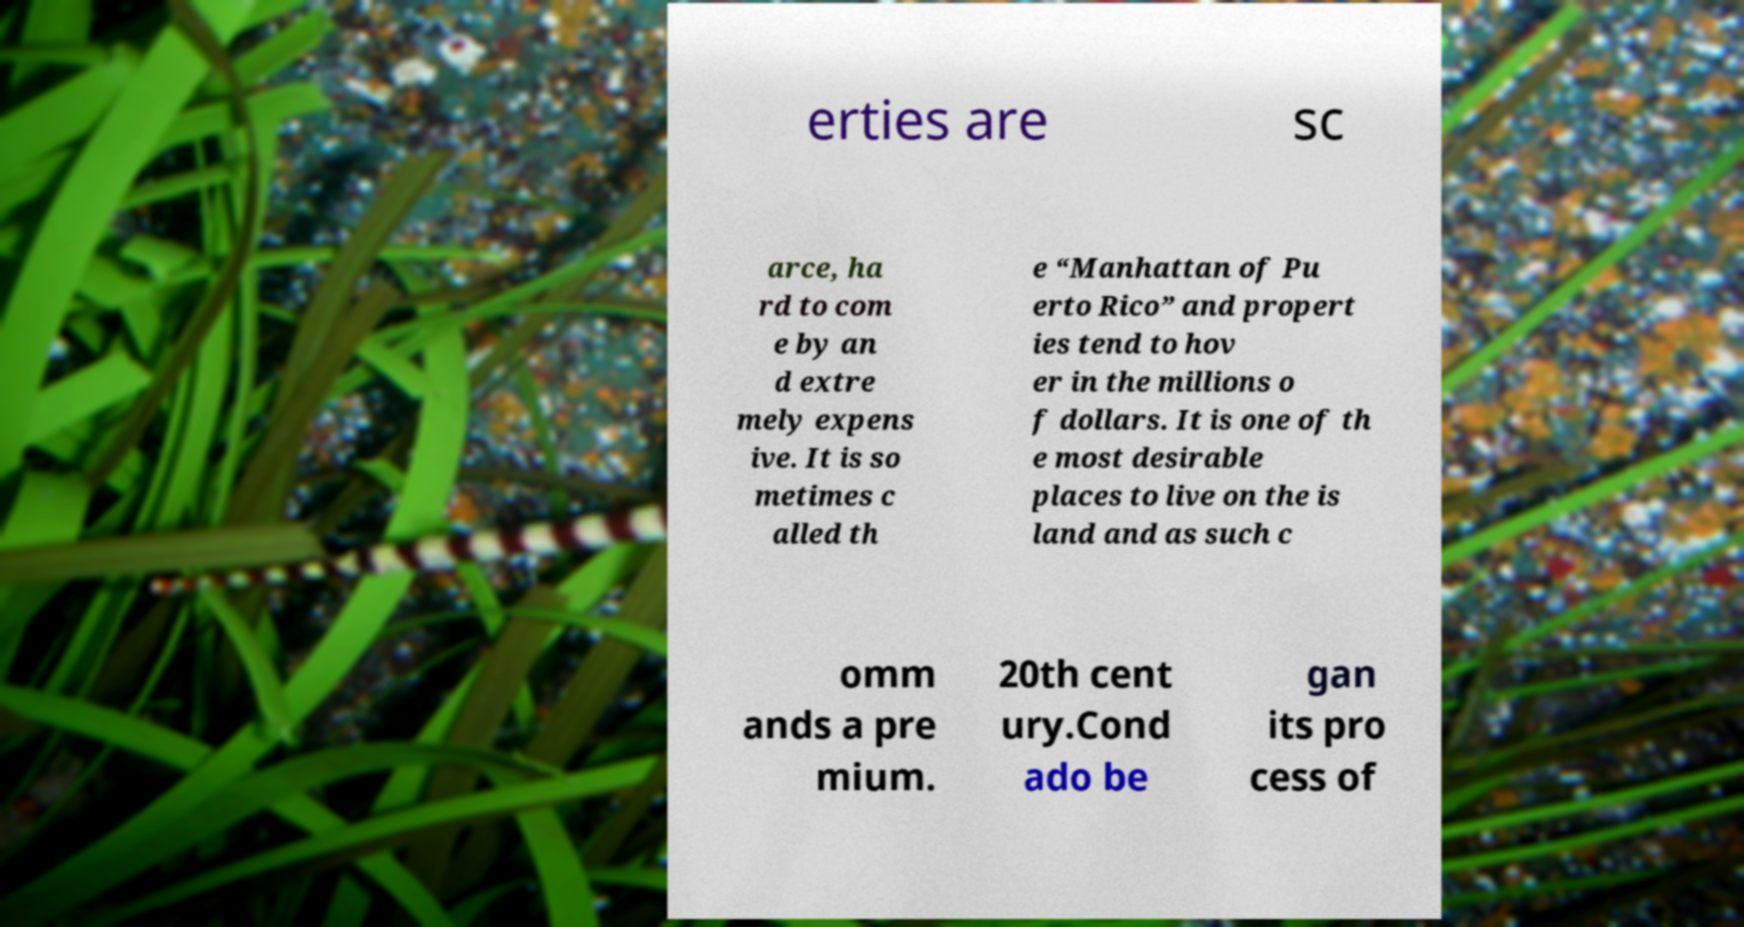For documentation purposes, I need the text within this image transcribed. Could you provide that? erties are sc arce, ha rd to com e by an d extre mely expens ive. It is so metimes c alled th e “Manhattan of Pu erto Rico” and propert ies tend to hov er in the millions o f dollars. It is one of th e most desirable places to live on the is land and as such c omm ands a pre mium. 20th cent ury.Cond ado be gan its pro cess of 